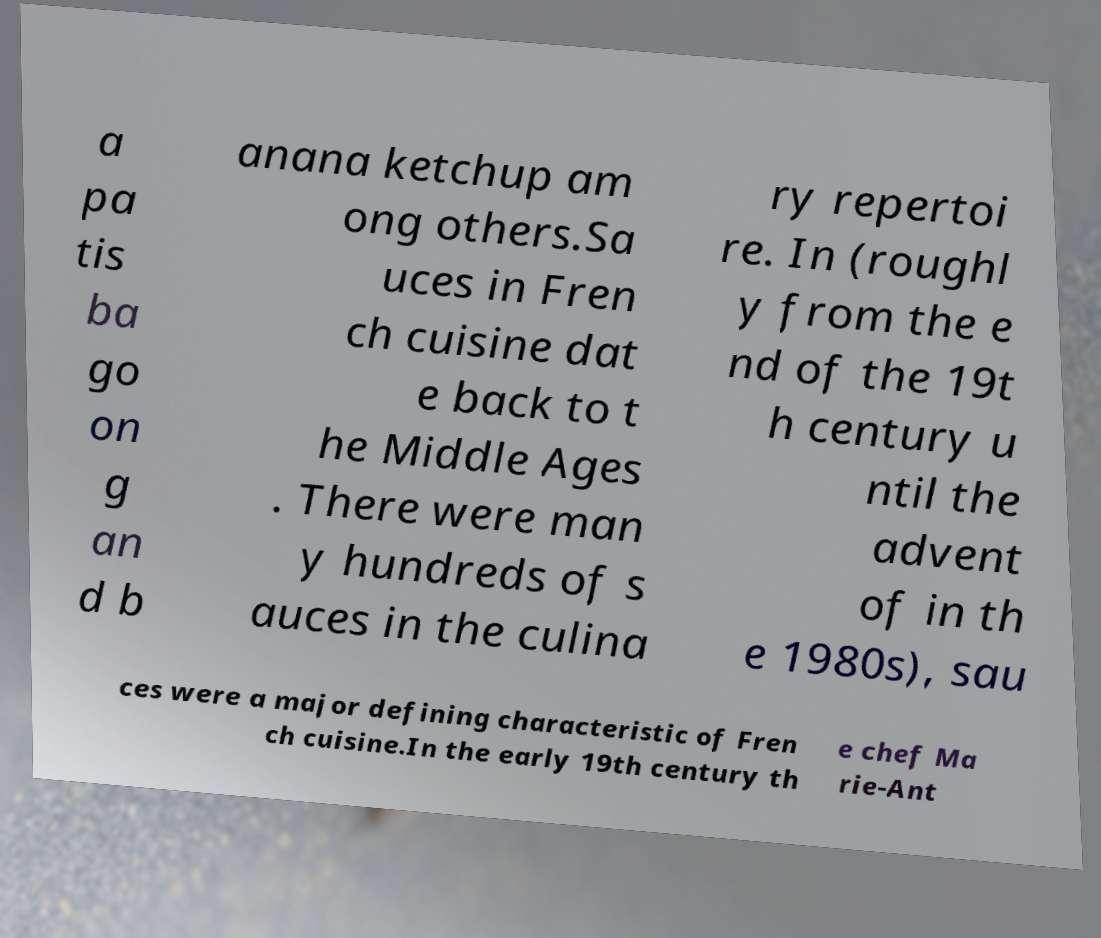Please identify and transcribe the text found in this image. a pa tis ba go on g an d b anana ketchup am ong others.Sa uces in Fren ch cuisine dat e back to t he Middle Ages . There were man y hundreds of s auces in the culina ry repertoi re. In (roughl y from the e nd of the 19t h century u ntil the advent of in th e 1980s), sau ces were a major defining characteristic of Fren ch cuisine.In the early 19th century th e chef Ma rie-Ant 